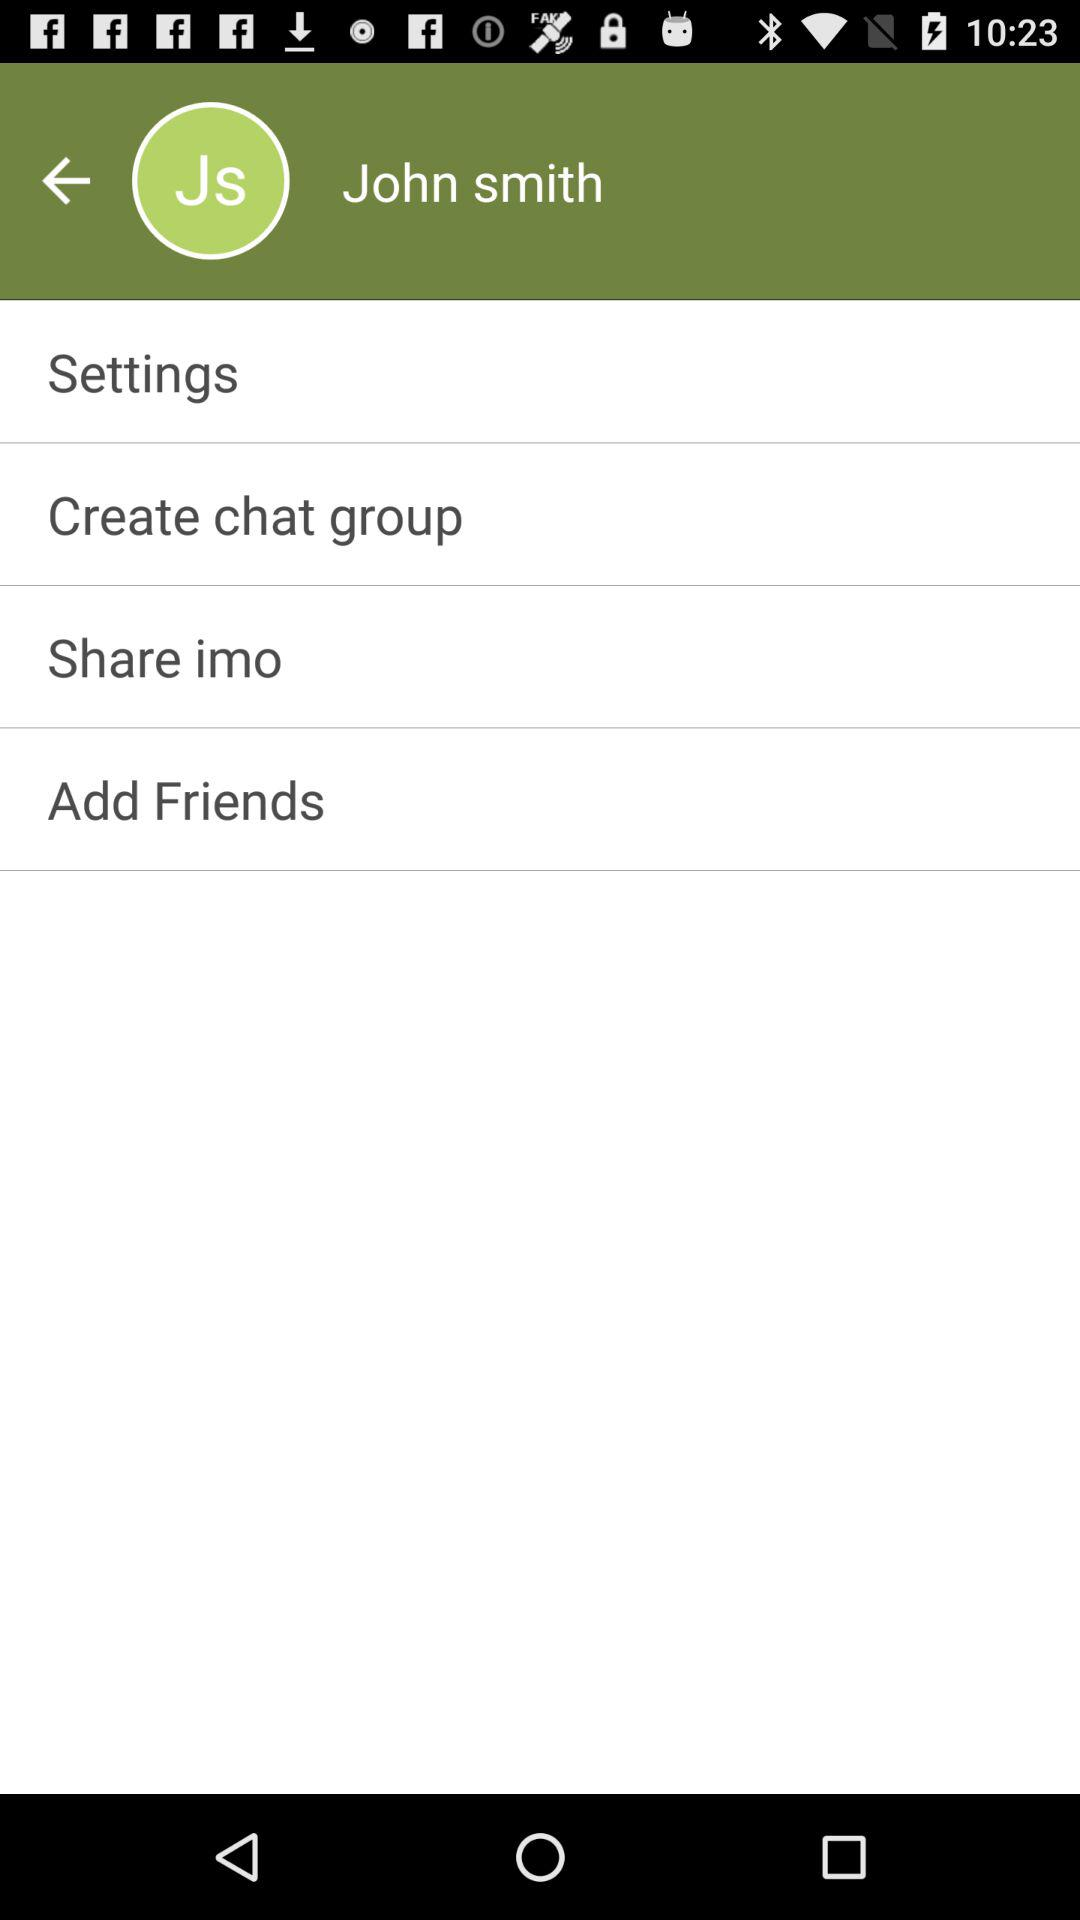What is the given profile name? The profile name is John Smith. 